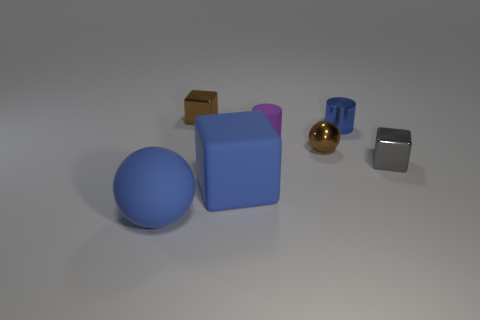Can you describe the texture and color of the objects furthest to the right? Certainly! The object furthest to the right in the image has a polished metallic texture, reflecting light on its surface. Its color is a silvery-gray, typical of stainless steel or aluminum. Opposite to it, there's a smaller object with a similar metallic sheen, yet with a distinct golden hue. And what about the other objects in the image, how do they compare? In contrast to the metallic objects, there is a collection of matte items as well. To the left, there's a blue sphere and a larger purplish-blue cube, both exhibiting a dull, non-reflective surface that suggests a rubbery or plastic material. There's also a small brown object, somewhat cube-shaped, that appears to be made of cardboard, given its texture and color. 